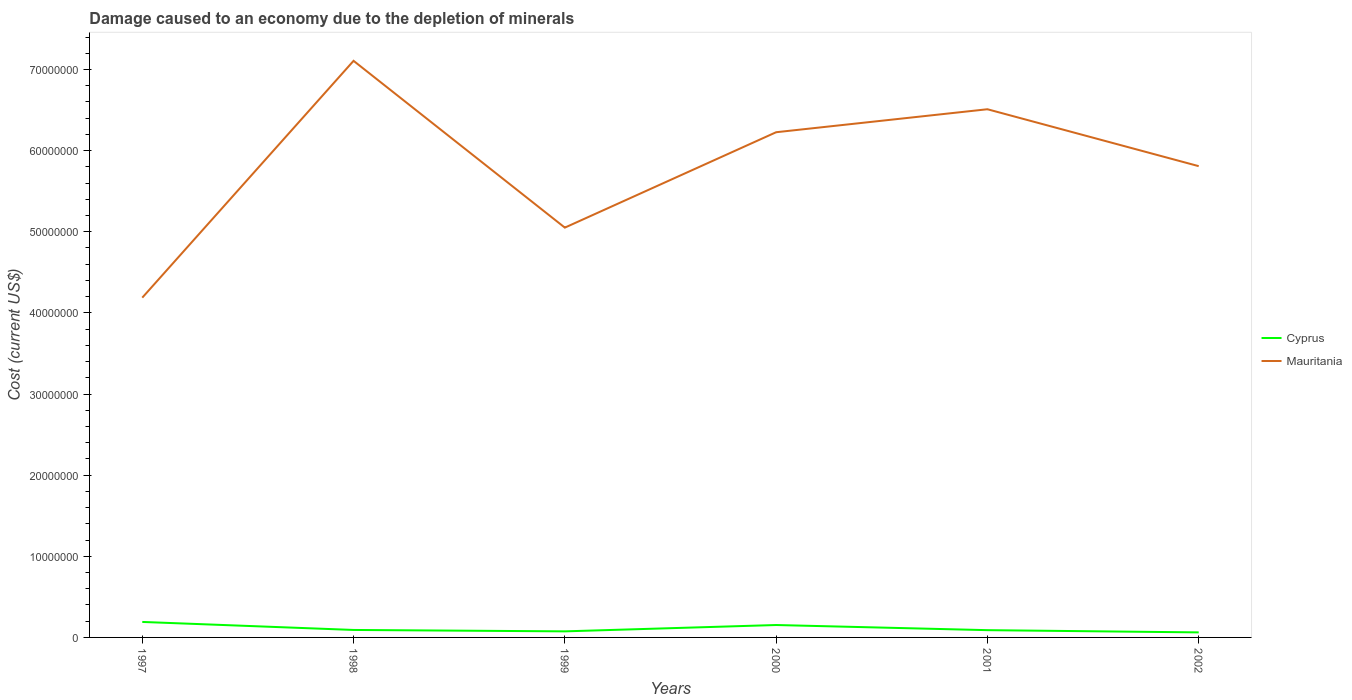How many different coloured lines are there?
Your response must be concise. 2. Is the number of lines equal to the number of legend labels?
Offer a terse response. Yes. Across all years, what is the maximum cost of damage caused due to the depletion of minerals in Cyprus?
Offer a terse response. 6.20e+05. What is the total cost of damage caused due to the depletion of minerals in Mauritania in the graph?
Give a very brief answer. 2.06e+07. What is the difference between the highest and the second highest cost of damage caused due to the depletion of minerals in Mauritania?
Make the answer very short. 2.92e+07. What is the difference between the highest and the lowest cost of damage caused due to the depletion of minerals in Mauritania?
Provide a short and direct response. 3. What is the difference between two consecutive major ticks on the Y-axis?
Offer a terse response. 1.00e+07. Does the graph contain any zero values?
Make the answer very short. No. How many legend labels are there?
Give a very brief answer. 2. What is the title of the graph?
Ensure brevity in your answer.  Damage caused to an economy due to the depletion of minerals. What is the label or title of the X-axis?
Give a very brief answer. Years. What is the label or title of the Y-axis?
Provide a succinct answer. Cost (current US$). What is the Cost (current US$) of Cyprus in 1997?
Keep it short and to the point. 1.91e+06. What is the Cost (current US$) in Mauritania in 1997?
Your answer should be compact. 4.19e+07. What is the Cost (current US$) of Cyprus in 1998?
Offer a very short reply. 9.21e+05. What is the Cost (current US$) in Mauritania in 1998?
Provide a succinct answer. 7.11e+07. What is the Cost (current US$) in Cyprus in 1999?
Your answer should be very brief. 7.48e+05. What is the Cost (current US$) of Mauritania in 1999?
Your response must be concise. 5.05e+07. What is the Cost (current US$) of Cyprus in 2000?
Ensure brevity in your answer.  1.53e+06. What is the Cost (current US$) in Mauritania in 2000?
Give a very brief answer. 6.23e+07. What is the Cost (current US$) in Cyprus in 2001?
Your answer should be very brief. 8.95e+05. What is the Cost (current US$) of Mauritania in 2001?
Your answer should be very brief. 6.51e+07. What is the Cost (current US$) of Cyprus in 2002?
Provide a short and direct response. 6.20e+05. What is the Cost (current US$) of Mauritania in 2002?
Your answer should be very brief. 5.81e+07. Across all years, what is the maximum Cost (current US$) in Cyprus?
Ensure brevity in your answer.  1.91e+06. Across all years, what is the maximum Cost (current US$) of Mauritania?
Provide a succinct answer. 7.11e+07. Across all years, what is the minimum Cost (current US$) in Cyprus?
Your answer should be compact. 6.20e+05. Across all years, what is the minimum Cost (current US$) in Mauritania?
Your answer should be compact. 4.19e+07. What is the total Cost (current US$) of Cyprus in the graph?
Your response must be concise. 6.62e+06. What is the total Cost (current US$) of Mauritania in the graph?
Keep it short and to the point. 3.49e+08. What is the difference between the Cost (current US$) of Cyprus in 1997 and that in 1998?
Your answer should be very brief. 9.89e+05. What is the difference between the Cost (current US$) in Mauritania in 1997 and that in 1998?
Provide a succinct answer. -2.92e+07. What is the difference between the Cost (current US$) in Cyprus in 1997 and that in 1999?
Ensure brevity in your answer.  1.16e+06. What is the difference between the Cost (current US$) in Mauritania in 1997 and that in 1999?
Provide a succinct answer. -8.63e+06. What is the difference between the Cost (current US$) of Cyprus in 1997 and that in 2000?
Your response must be concise. 3.79e+05. What is the difference between the Cost (current US$) of Mauritania in 1997 and that in 2000?
Make the answer very short. -2.04e+07. What is the difference between the Cost (current US$) of Cyprus in 1997 and that in 2001?
Ensure brevity in your answer.  1.01e+06. What is the difference between the Cost (current US$) of Mauritania in 1997 and that in 2001?
Offer a very short reply. -2.32e+07. What is the difference between the Cost (current US$) of Cyprus in 1997 and that in 2002?
Make the answer very short. 1.29e+06. What is the difference between the Cost (current US$) of Mauritania in 1997 and that in 2002?
Provide a succinct answer. -1.62e+07. What is the difference between the Cost (current US$) in Cyprus in 1998 and that in 1999?
Provide a succinct answer. 1.72e+05. What is the difference between the Cost (current US$) of Mauritania in 1998 and that in 1999?
Provide a succinct answer. 2.06e+07. What is the difference between the Cost (current US$) of Cyprus in 1998 and that in 2000?
Give a very brief answer. -6.10e+05. What is the difference between the Cost (current US$) in Mauritania in 1998 and that in 2000?
Offer a very short reply. 8.80e+06. What is the difference between the Cost (current US$) of Cyprus in 1998 and that in 2001?
Offer a terse response. 2.55e+04. What is the difference between the Cost (current US$) of Mauritania in 1998 and that in 2001?
Your response must be concise. 5.97e+06. What is the difference between the Cost (current US$) of Cyprus in 1998 and that in 2002?
Ensure brevity in your answer.  3.01e+05. What is the difference between the Cost (current US$) in Mauritania in 1998 and that in 2002?
Provide a succinct answer. 1.30e+07. What is the difference between the Cost (current US$) of Cyprus in 1999 and that in 2000?
Offer a terse response. -7.82e+05. What is the difference between the Cost (current US$) in Mauritania in 1999 and that in 2000?
Keep it short and to the point. -1.18e+07. What is the difference between the Cost (current US$) in Cyprus in 1999 and that in 2001?
Offer a terse response. -1.47e+05. What is the difference between the Cost (current US$) of Mauritania in 1999 and that in 2001?
Provide a short and direct response. -1.46e+07. What is the difference between the Cost (current US$) of Cyprus in 1999 and that in 2002?
Your answer should be very brief. 1.28e+05. What is the difference between the Cost (current US$) of Mauritania in 1999 and that in 2002?
Your response must be concise. -7.58e+06. What is the difference between the Cost (current US$) in Cyprus in 2000 and that in 2001?
Make the answer very short. 6.35e+05. What is the difference between the Cost (current US$) of Mauritania in 2000 and that in 2001?
Your answer should be very brief. -2.83e+06. What is the difference between the Cost (current US$) of Cyprus in 2000 and that in 2002?
Offer a terse response. 9.10e+05. What is the difference between the Cost (current US$) in Mauritania in 2000 and that in 2002?
Keep it short and to the point. 4.18e+06. What is the difference between the Cost (current US$) of Cyprus in 2001 and that in 2002?
Provide a short and direct response. 2.75e+05. What is the difference between the Cost (current US$) of Mauritania in 2001 and that in 2002?
Offer a very short reply. 7.01e+06. What is the difference between the Cost (current US$) of Cyprus in 1997 and the Cost (current US$) of Mauritania in 1998?
Your answer should be compact. -6.92e+07. What is the difference between the Cost (current US$) in Cyprus in 1997 and the Cost (current US$) in Mauritania in 1999?
Give a very brief answer. -4.86e+07. What is the difference between the Cost (current US$) in Cyprus in 1997 and the Cost (current US$) in Mauritania in 2000?
Your response must be concise. -6.04e+07. What is the difference between the Cost (current US$) of Cyprus in 1997 and the Cost (current US$) of Mauritania in 2001?
Your answer should be very brief. -6.32e+07. What is the difference between the Cost (current US$) of Cyprus in 1997 and the Cost (current US$) of Mauritania in 2002?
Your answer should be very brief. -5.62e+07. What is the difference between the Cost (current US$) of Cyprus in 1998 and the Cost (current US$) of Mauritania in 1999?
Provide a succinct answer. -4.96e+07. What is the difference between the Cost (current US$) of Cyprus in 1998 and the Cost (current US$) of Mauritania in 2000?
Provide a short and direct response. -6.13e+07. What is the difference between the Cost (current US$) in Cyprus in 1998 and the Cost (current US$) in Mauritania in 2001?
Your answer should be compact. -6.42e+07. What is the difference between the Cost (current US$) in Cyprus in 1998 and the Cost (current US$) in Mauritania in 2002?
Give a very brief answer. -5.72e+07. What is the difference between the Cost (current US$) in Cyprus in 1999 and the Cost (current US$) in Mauritania in 2000?
Provide a short and direct response. -6.15e+07. What is the difference between the Cost (current US$) of Cyprus in 1999 and the Cost (current US$) of Mauritania in 2001?
Give a very brief answer. -6.43e+07. What is the difference between the Cost (current US$) of Cyprus in 1999 and the Cost (current US$) of Mauritania in 2002?
Give a very brief answer. -5.73e+07. What is the difference between the Cost (current US$) in Cyprus in 2000 and the Cost (current US$) in Mauritania in 2001?
Make the answer very short. -6.36e+07. What is the difference between the Cost (current US$) in Cyprus in 2000 and the Cost (current US$) in Mauritania in 2002?
Ensure brevity in your answer.  -5.66e+07. What is the difference between the Cost (current US$) in Cyprus in 2001 and the Cost (current US$) in Mauritania in 2002?
Offer a terse response. -5.72e+07. What is the average Cost (current US$) in Cyprus per year?
Your answer should be very brief. 1.10e+06. What is the average Cost (current US$) of Mauritania per year?
Make the answer very short. 5.81e+07. In the year 1997, what is the difference between the Cost (current US$) of Cyprus and Cost (current US$) of Mauritania?
Your answer should be very brief. -4.00e+07. In the year 1998, what is the difference between the Cost (current US$) of Cyprus and Cost (current US$) of Mauritania?
Give a very brief answer. -7.01e+07. In the year 1999, what is the difference between the Cost (current US$) in Cyprus and Cost (current US$) in Mauritania?
Your answer should be very brief. -4.98e+07. In the year 2000, what is the difference between the Cost (current US$) in Cyprus and Cost (current US$) in Mauritania?
Offer a terse response. -6.07e+07. In the year 2001, what is the difference between the Cost (current US$) in Cyprus and Cost (current US$) in Mauritania?
Make the answer very short. -6.42e+07. In the year 2002, what is the difference between the Cost (current US$) in Cyprus and Cost (current US$) in Mauritania?
Make the answer very short. -5.75e+07. What is the ratio of the Cost (current US$) of Cyprus in 1997 to that in 1998?
Keep it short and to the point. 2.07. What is the ratio of the Cost (current US$) of Mauritania in 1997 to that in 1998?
Ensure brevity in your answer.  0.59. What is the ratio of the Cost (current US$) in Cyprus in 1997 to that in 1999?
Give a very brief answer. 2.55. What is the ratio of the Cost (current US$) of Mauritania in 1997 to that in 1999?
Offer a very short reply. 0.83. What is the ratio of the Cost (current US$) of Cyprus in 1997 to that in 2000?
Your answer should be compact. 1.25. What is the ratio of the Cost (current US$) in Mauritania in 1997 to that in 2000?
Provide a short and direct response. 0.67. What is the ratio of the Cost (current US$) in Cyprus in 1997 to that in 2001?
Offer a terse response. 2.13. What is the ratio of the Cost (current US$) in Mauritania in 1997 to that in 2001?
Keep it short and to the point. 0.64. What is the ratio of the Cost (current US$) in Cyprus in 1997 to that in 2002?
Make the answer very short. 3.08. What is the ratio of the Cost (current US$) of Mauritania in 1997 to that in 2002?
Keep it short and to the point. 0.72. What is the ratio of the Cost (current US$) in Cyprus in 1998 to that in 1999?
Make the answer very short. 1.23. What is the ratio of the Cost (current US$) in Mauritania in 1998 to that in 1999?
Your response must be concise. 1.41. What is the ratio of the Cost (current US$) of Cyprus in 1998 to that in 2000?
Give a very brief answer. 0.6. What is the ratio of the Cost (current US$) of Mauritania in 1998 to that in 2000?
Ensure brevity in your answer.  1.14. What is the ratio of the Cost (current US$) of Cyprus in 1998 to that in 2001?
Ensure brevity in your answer.  1.03. What is the ratio of the Cost (current US$) in Mauritania in 1998 to that in 2001?
Your answer should be compact. 1.09. What is the ratio of the Cost (current US$) in Cyprus in 1998 to that in 2002?
Your answer should be very brief. 1.49. What is the ratio of the Cost (current US$) in Mauritania in 1998 to that in 2002?
Provide a short and direct response. 1.22. What is the ratio of the Cost (current US$) in Cyprus in 1999 to that in 2000?
Give a very brief answer. 0.49. What is the ratio of the Cost (current US$) of Mauritania in 1999 to that in 2000?
Provide a short and direct response. 0.81. What is the ratio of the Cost (current US$) in Cyprus in 1999 to that in 2001?
Your response must be concise. 0.84. What is the ratio of the Cost (current US$) in Mauritania in 1999 to that in 2001?
Your response must be concise. 0.78. What is the ratio of the Cost (current US$) of Cyprus in 1999 to that in 2002?
Offer a terse response. 1.21. What is the ratio of the Cost (current US$) in Mauritania in 1999 to that in 2002?
Your response must be concise. 0.87. What is the ratio of the Cost (current US$) in Cyprus in 2000 to that in 2001?
Make the answer very short. 1.71. What is the ratio of the Cost (current US$) of Mauritania in 2000 to that in 2001?
Keep it short and to the point. 0.96. What is the ratio of the Cost (current US$) of Cyprus in 2000 to that in 2002?
Ensure brevity in your answer.  2.47. What is the ratio of the Cost (current US$) of Mauritania in 2000 to that in 2002?
Your answer should be very brief. 1.07. What is the ratio of the Cost (current US$) in Cyprus in 2001 to that in 2002?
Provide a succinct answer. 1.44. What is the ratio of the Cost (current US$) in Mauritania in 2001 to that in 2002?
Offer a terse response. 1.12. What is the difference between the highest and the second highest Cost (current US$) of Cyprus?
Offer a very short reply. 3.79e+05. What is the difference between the highest and the second highest Cost (current US$) of Mauritania?
Offer a terse response. 5.97e+06. What is the difference between the highest and the lowest Cost (current US$) of Cyprus?
Your answer should be compact. 1.29e+06. What is the difference between the highest and the lowest Cost (current US$) of Mauritania?
Your answer should be compact. 2.92e+07. 